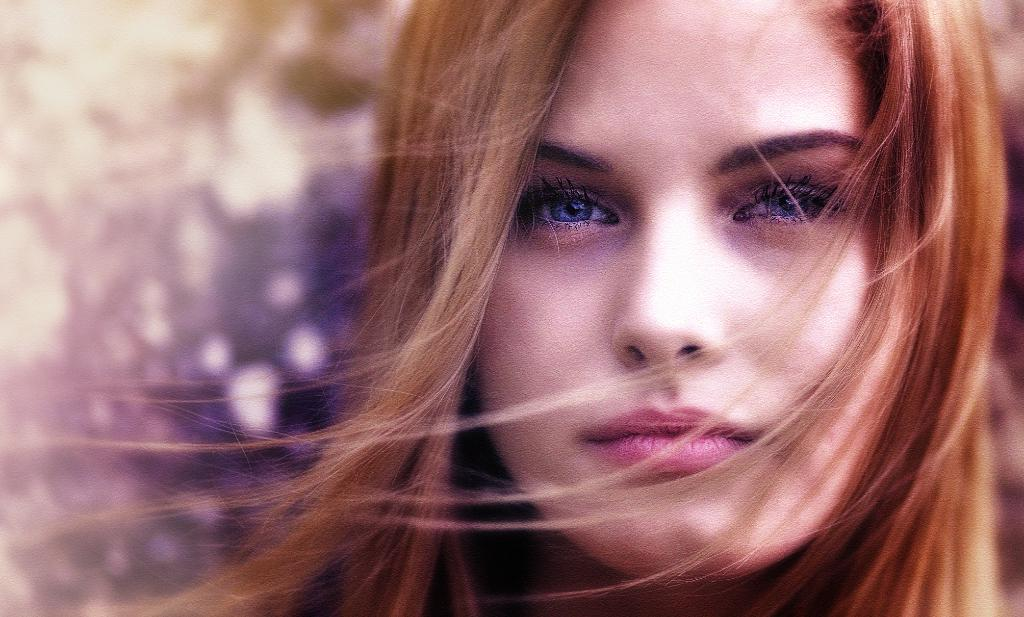Who is the main subject in the image? There is a woman in the image. What can be observed about the woman's eyes? The woman has blue eyes. What is the color of the woman's hair? The woman has brown hair. How would you describe the background of the image? The background of the image is blurred. What type of juice is the woman holding in the image? There is no juice present in the image; the woman is the main subject, and no other objects are mentioned. 